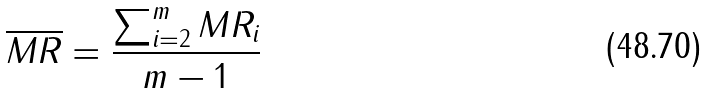Convert formula to latex. <formula><loc_0><loc_0><loc_500><loc_500>\overline { M R } = \frac { \sum _ { i = 2 } ^ { m } M R _ { i } } { m - 1 }</formula> 